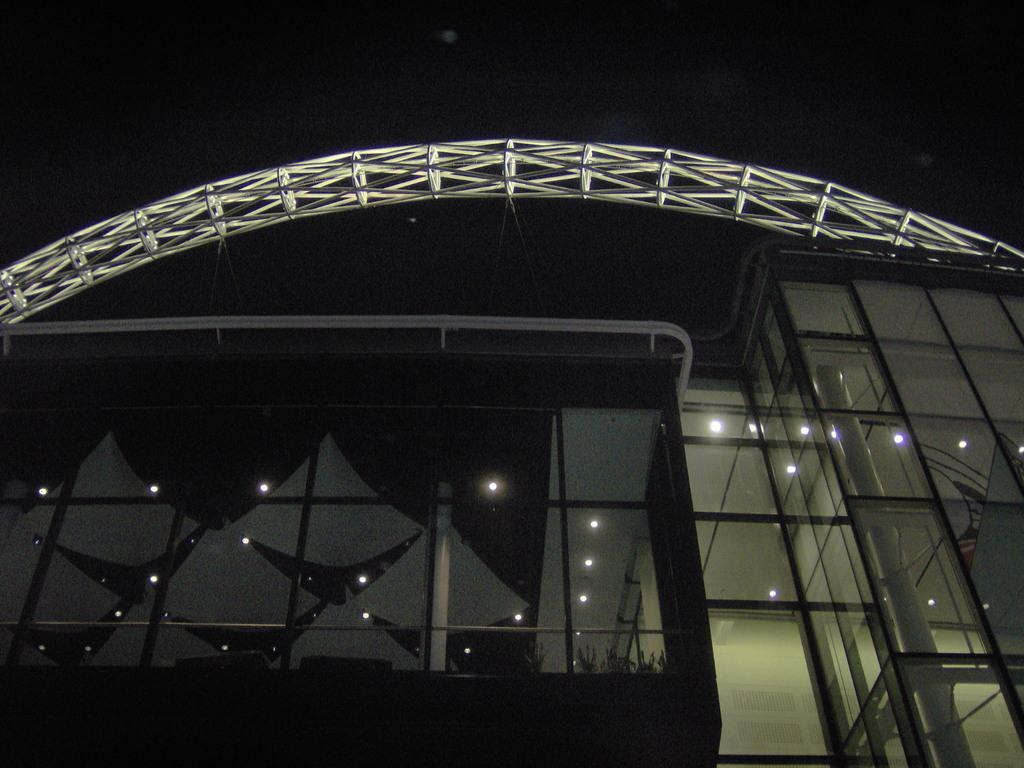Please provide a concise description of this image. This image consists of a building to which there are glasses. At the top, there is a stand. The sky is black in color. 